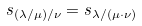Convert formula to latex. <formula><loc_0><loc_0><loc_500><loc_500>s _ { ( \lambda / \mu ) / \nu } = s _ { \lambda / ( \mu \cdot \nu ) }</formula> 